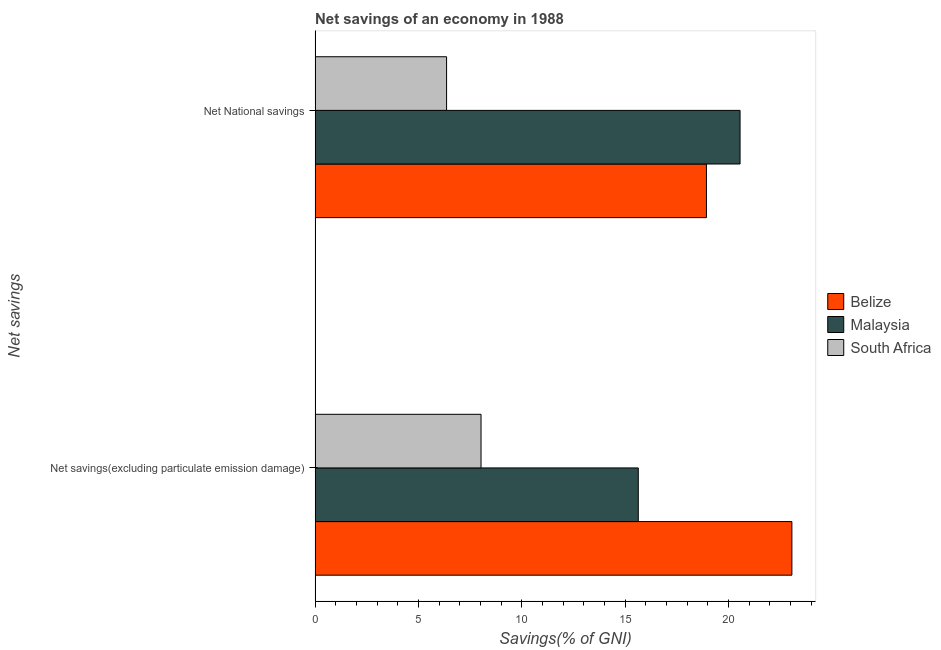How many different coloured bars are there?
Ensure brevity in your answer.  3. How many bars are there on the 2nd tick from the bottom?
Your answer should be very brief. 3. What is the label of the 2nd group of bars from the top?
Offer a terse response. Net savings(excluding particulate emission damage). What is the net savings(excluding particulate emission damage) in Belize?
Ensure brevity in your answer.  23.07. Across all countries, what is the maximum net savings(excluding particulate emission damage)?
Offer a very short reply. 23.07. Across all countries, what is the minimum net savings(excluding particulate emission damage)?
Provide a short and direct response. 8.03. In which country was the net national savings maximum?
Ensure brevity in your answer.  Malaysia. In which country was the net savings(excluding particulate emission damage) minimum?
Offer a terse response. South Africa. What is the total net savings(excluding particulate emission damage) in the graph?
Your answer should be compact. 46.74. What is the difference between the net savings(excluding particulate emission damage) in South Africa and that in Belize?
Your answer should be compact. -15.04. What is the difference between the net savings(excluding particulate emission damage) in Malaysia and the net national savings in Belize?
Your answer should be very brief. -3.3. What is the average net national savings per country?
Offer a terse response. 15.29. What is the difference between the net savings(excluding particulate emission damage) and net national savings in South Africa?
Make the answer very short. 1.67. In how many countries, is the net national savings greater than 11 %?
Make the answer very short. 2. What is the ratio of the net savings(excluding particulate emission damage) in Belize to that in Malaysia?
Give a very brief answer. 1.48. Is the net national savings in Belize less than that in Malaysia?
Offer a terse response. Yes. In how many countries, is the net savings(excluding particulate emission damage) greater than the average net savings(excluding particulate emission damage) taken over all countries?
Keep it short and to the point. 2. What does the 2nd bar from the top in Net National savings represents?
Keep it short and to the point. Malaysia. What does the 2nd bar from the bottom in Net savings(excluding particulate emission damage) represents?
Offer a terse response. Malaysia. How many bars are there?
Offer a terse response. 6. Are all the bars in the graph horizontal?
Keep it short and to the point. Yes. Does the graph contain any zero values?
Give a very brief answer. No. Does the graph contain grids?
Offer a very short reply. No. Where does the legend appear in the graph?
Ensure brevity in your answer.  Center right. How are the legend labels stacked?
Offer a very short reply. Vertical. What is the title of the graph?
Your response must be concise. Net savings of an economy in 1988. Does "Croatia" appear as one of the legend labels in the graph?
Ensure brevity in your answer.  No. What is the label or title of the X-axis?
Your response must be concise. Savings(% of GNI). What is the label or title of the Y-axis?
Your answer should be compact. Net savings. What is the Savings(% of GNI) of Belize in Net savings(excluding particulate emission damage)?
Keep it short and to the point. 23.07. What is the Savings(% of GNI) in Malaysia in Net savings(excluding particulate emission damage)?
Make the answer very short. 15.64. What is the Savings(% of GNI) of South Africa in Net savings(excluding particulate emission damage)?
Give a very brief answer. 8.03. What is the Savings(% of GNI) in Belize in Net National savings?
Offer a very short reply. 18.94. What is the Savings(% of GNI) of Malaysia in Net National savings?
Ensure brevity in your answer.  20.56. What is the Savings(% of GNI) in South Africa in Net National savings?
Your answer should be compact. 6.36. Across all Net savings, what is the maximum Savings(% of GNI) of Belize?
Your response must be concise. 23.07. Across all Net savings, what is the maximum Savings(% of GNI) of Malaysia?
Offer a terse response. 20.56. Across all Net savings, what is the maximum Savings(% of GNI) of South Africa?
Provide a short and direct response. 8.03. Across all Net savings, what is the minimum Savings(% of GNI) of Belize?
Provide a succinct answer. 18.94. Across all Net savings, what is the minimum Savings(% of GNI) of Malaysia?
Your answer should be compact. 15.64. Across all Net savings, what is the minimum Savings(% of GNI) of South Africa?
Your response must be concise. 6.36. What is the total Savings(% of GNI) of Belize in the graph?
Make the answer very short. 42.01. What is the total Savings(% of GNI) in Malaysia in the graph?
Provide a short and direct response. 36.2. What is the total Savings(% of GNI) in South Africa in the graph?
Provide a short and direct response. 14.39. What is the difference between the Savings(% of GNI) in Belize in Net savings(excluding particulate emission damage) and that in Net National savings?
Make the answer very short. 4.13. What is the difference between the Savings(% of GNI) in Malaysia in Net savings(excluding particulate emission damage) and that in Net National savings?
Give a very brief answer. -4.93. What is the difference between the Savings(% of GNI) of South Africa in Net savings(excluding particulate emission damage) and that in Net National savings?
Make the answer very short. 1.67. What is the difference between the Savings(% of GNI) of Belize in Net savings(excluding particulate emission damage) and the Savings(% of GNI) of Malaysia in Net National savings?
Keep it short and to the point. 2.51. What is the difference between the Savings(% of GNI) of Belize in Net savings(excluding particulate emission damage) and the Savings(% of GNI) of South Africa in Net National savings?
Offer a terse response. 16.71. What is the difference between the Savings(% of GNI) in Malaysia in Net savings(excluding particulate emission damage) and the Savings(% of GNI) in South Africa in Net National savings?
Your response must be concise. 9.28. What is the average Savings(% of GNI) in Belize per Net savings?
Your answer should be very brief. 21.01. What is the average Savings(% of GNI) in Malaysia per Net savings?
Your response must be concise. 18.1. What is the average Savings(% of GNI) of South Africa per Net savings?
Offer a very short reply. 7.2. What is the difference between the Savings(% of GNI) of Belize and Savings(% of GNI) of Malaysia in Net savings(excluding particulate emission damage)?
Give a very brief answer. 7.43. What is the difference between the Savings(% of GNI) of Belize and Savings(% of GNI) of South Africa in Net savings(excluding particulate emission damage)?
Your answer should be compact. 15.04. What is the difference between the Savings(% of GNI) in Malaysia and Savings(% of GNI) in South Africa in Net savings(excluding particulate emission damage)?
Your answer should be compact. 7.61. What is the difference between the Savings(% of GNI) in Belize and Savings(% of GNI) in Malaysia in Net National savings?
Give a very brief answer. -1.63. What is the difference between the Savings(% of GNI) in Belize and Savings(% of GNI) in South Africa in Net National savings?
Offer a terse response. 12.58. What is the difference between the Savings(% of GNI) of Malaysia and Savings(% of GNI) of South Africa in Net National savings?
Your answer should be very brief. 14.2. What is the ratio of the Savings(% of GNI) in Belize in Net savings(excluding particulate emission damage) to that in Net National savings?
Your answer should be very brief. 1.22. What is the ratio of the Savings(% of GNI) in Malaysia in Net savings(excluding particulate emission damage) to that in Net National savings?
Provide a succinct answer. 0.76. What is the ratio of the Savings(% of GNI) of South Africa in Net savings(excluding particulate emission damage) to that in Net National savings?
Keep it short and to the point. 1.26. What is the difference between the highest and the second highest Savings(% of GNI) of Belize?
Offer a very short reply. 4.13. What is the difference between the highest and the second highest Savings(% of GNI) in Malaysia?
Provide a short and direct response. 4.93. What is the difference between the highest and the second highest Savings(% of GNI) in South Africa?
Offer a very short reply. 1.67. What is the difference between the highest and the lowest Savings(% of GNI) of Belize?
Your answer should be compact. 4.13. What is the difference between the highest and the lowest Savings(% of GNI) of Malaysia?
Your answer should be compact. 4.93. What is the difference between the highest and the lowest Savings(% of GNI) of South Africa?
Offer a terse response. 1.67. 